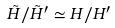Convert formula to latex. <formula><loc_0><loc_0><loc_500><loc_500>\tilde { H } / \tilde { H } ^ { \prime } \simeq H / H ^ { \prime }</formula> 